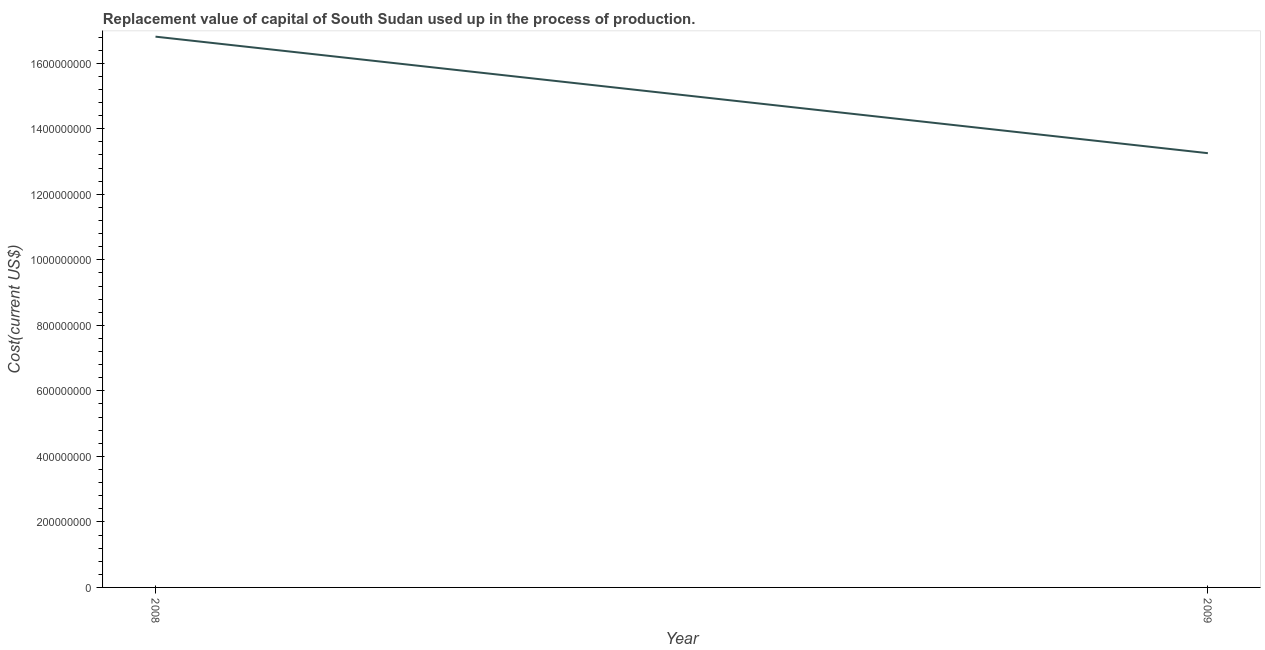What is the consumption of fixed capital in 2009?
Ensure brevity in your answer.  1.33e+09. Across all years, what is the maximum consumption of fixed capital?
Keep it short and to the point. 1.68e+09. Across all years, what is the minimum consumption of fixed capital?
Provide a short and direct response. 1.33e+09. What is the sum of the consumption of fixed capital?
Ensure brevity in your answer.  3.01e+09. What is the difference between the consumption of fixed capital in 2008 and 2009?
Ensure brevity in your answer.  3.56e+08. What is the average consumption of fixed capital per year?
Your response must be concise. 1.50e+09. What is the median consumption of fixed capital?
Provide a short and direct response. 1.50e+09. Do a majority of the years between 2009 and 2008 (inclusive) have consumption of fixed capital greater than 640000000 US$?
Your answer should be compact. No. What is the ratio of the consumption of fixed capital in 2008 to that in 2009?
Provide a short and direct response. 1.27. In how many years, is the consumption of fixed capital greater than the average consumption of fixed capital taken over all years?
Your answer should be compact. 1. How many lines are there?
Make the answer very short. 1. How many years are there in the graph?
Offer a very short reply. 2. Are the values on the major ticks of Y-axis written in scientific E-notation?
Provide a succinct answer. No. Does the graph contain grids?
Your answer should be compact. No. What is the title of the graph?
Give a very brief answer. Replacement value of capital of South Sudan used up in the process of production. What is the label or title of the X-axis?
Make the answer very short. Year. What is the label or title of the Y-axis?
Give a very brief answer. Cost(current US$). What is the Cost(current US$) of 2008?
Ensure brevity in your answer.  1.68e+09. What is the Cost(current US$) in 2009?
Offer a very short reply. 1.33e+09. What is the difference between the Cost(current US$) in 2008 and 2009?
Your answer should be compact. 3.56e+08. What is the ratio of the Cost(current US$) in 2008 to that in 2009?
Your answer should be very brief. 1.27. 